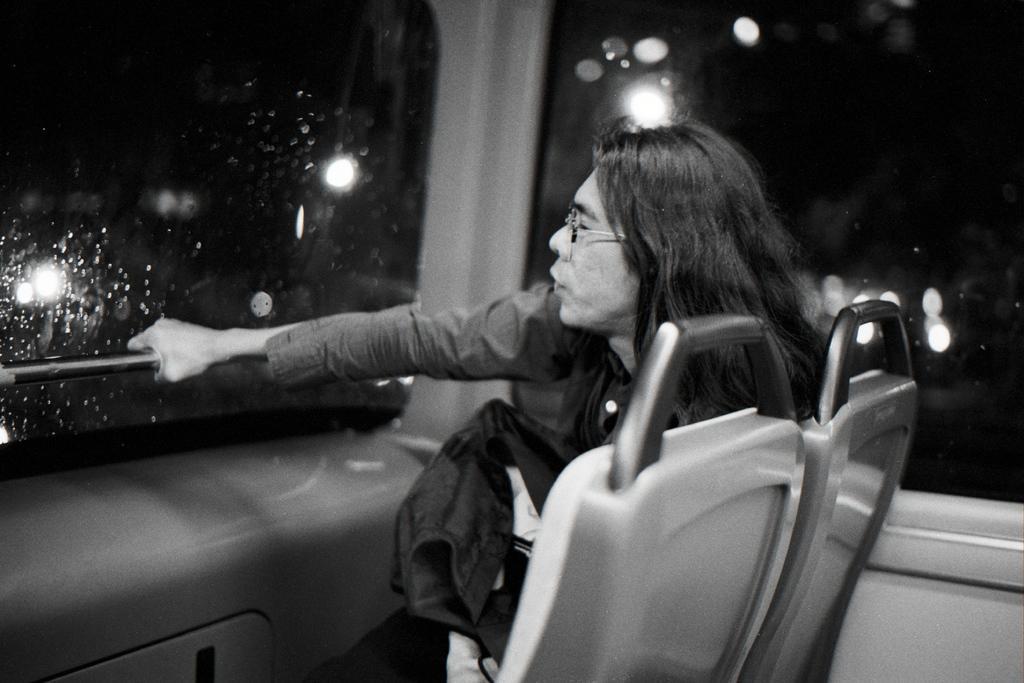In one or two sentences, can you explain what this image depicts? It is a black and white image and in this image we can see a woman sitting inside the vehicle and holding the rod. Lights are also visible in this image. 